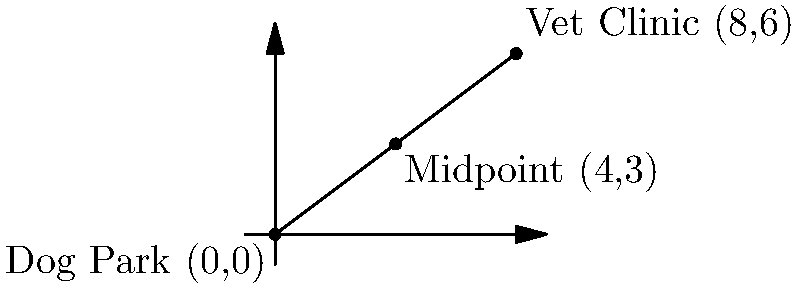As a responsible pet owner, you're planning a route that includes both the local dog park and your trusted veterinary clinic. The dog park is located at coordinates (0,0), and the vet clinic is at (8,6) on a city map. To ensure you're allocating your time efficiently, you want to find the midpoint of the line segment connecting these two locations. What are the coordinates of this midpoint? To find the midpoint of a line segment, we can use the midpoint formula:

$$ \text{Midpoint} = (\frac{x_1 + x_2}{2}, \frac{y_1 + y_2}{2}) $$

Where $(x_1, y_1)$ are the coordinates of the first point and $(x_2, y_2)$ are the coordinates of the second point.

Let's apply this formula to our scenario:

1. Dog Park coordinates: $(x_1, y_1) = (0, 0)$
2. Vet Clinic coordinates: $(x_2, y_2) = (8, 6)$

Now, let's calculate:

$$ x_{midpoint} = \frac{x_1 + x_2}{2} = \frac{0 + 8}{2} = \frac{8}{2} = 4 $$

$$ y_{midpoint} = \frac{y_1 + y_2}{2} = \frac{0 + 6}{2} = \frac{6}{2} = 3 $$

Therefore, the midpoint coordinates are (4, 3).
Answer: (4, 3) 